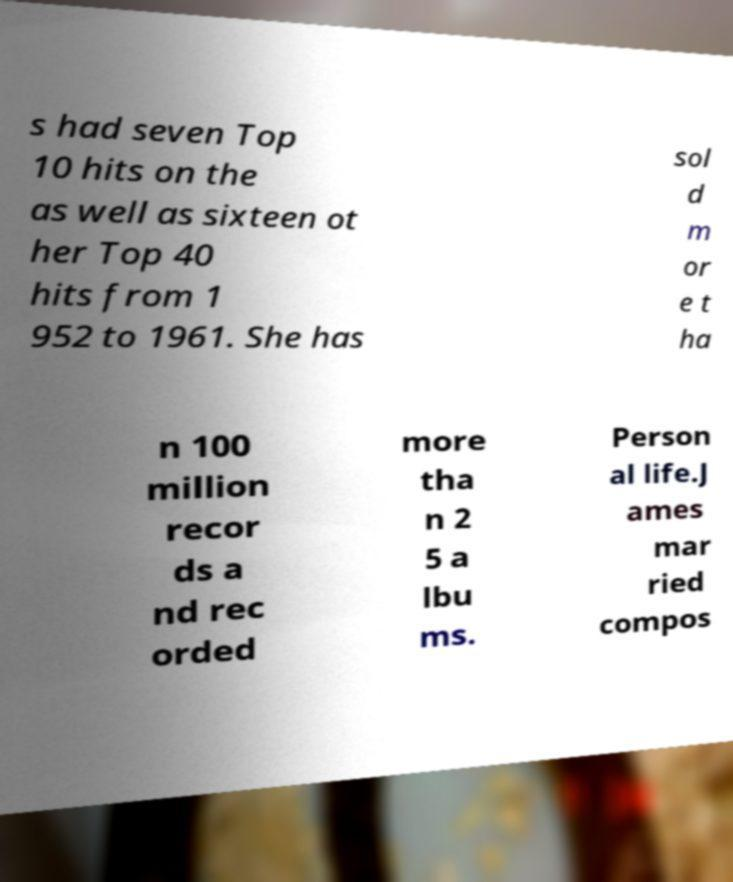For documentation purposes, I need the text within this image transcribed. Could you provide that? s had seven Top 10 hits on the as well as sixteen ot her Top 40 hits from 1 952 to 1961. She has sol d m or e t ha n 100 million recor ds a nd rec orded more tha n 2 5 a lbu ms. Person al life.J ames mar ried compos 